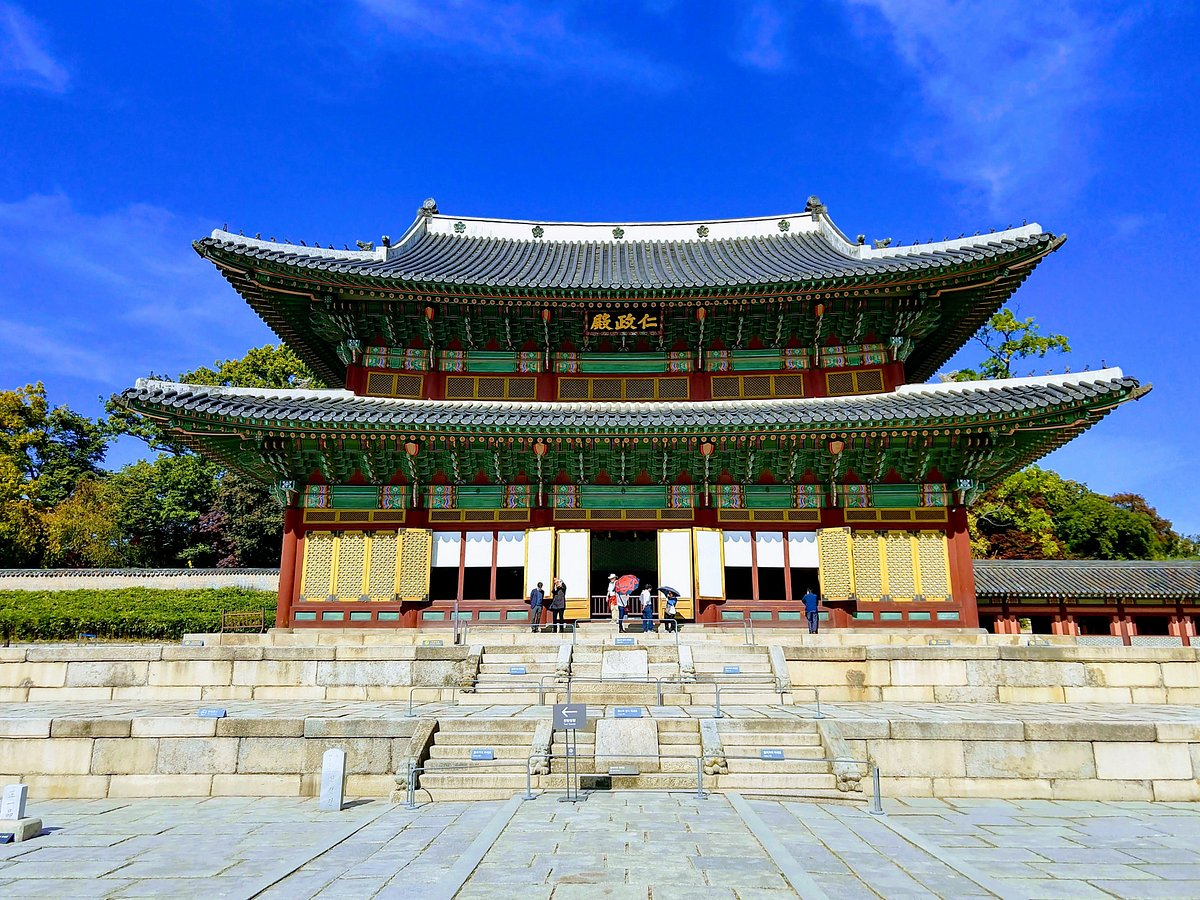What can you tell me about the roof structure visible in the picture? The roof structure of the Changdeokgung Palace Complex, particularly the 'paljak' or hip-and-gable roof, is an iconic element of traditional Korean architecture. This type of roofing is not only aesthetically pleasing with its graceful curves and upturned eaves but also functionally significant. It is designed to provide optimal drainage during Korea's rainy seasons, and the wide eaves offer shelter from both rain and sunlight, making the palace’s interiors cooler in summer and drier during rain. How does this architectural feature compare to similar structures in other parts of East Asia? While similar architectural features can be found throughout East Asia, Korean paljak roofs are distinctive for their gentle yet pronounced curves compared to the more sharply curved Chinese roofs and the generally straighter Japanese roofs. These variations reflect differing cultural priorities and environmental considerations, adapting over centuries to local conditions and aesthetic values in each region. 